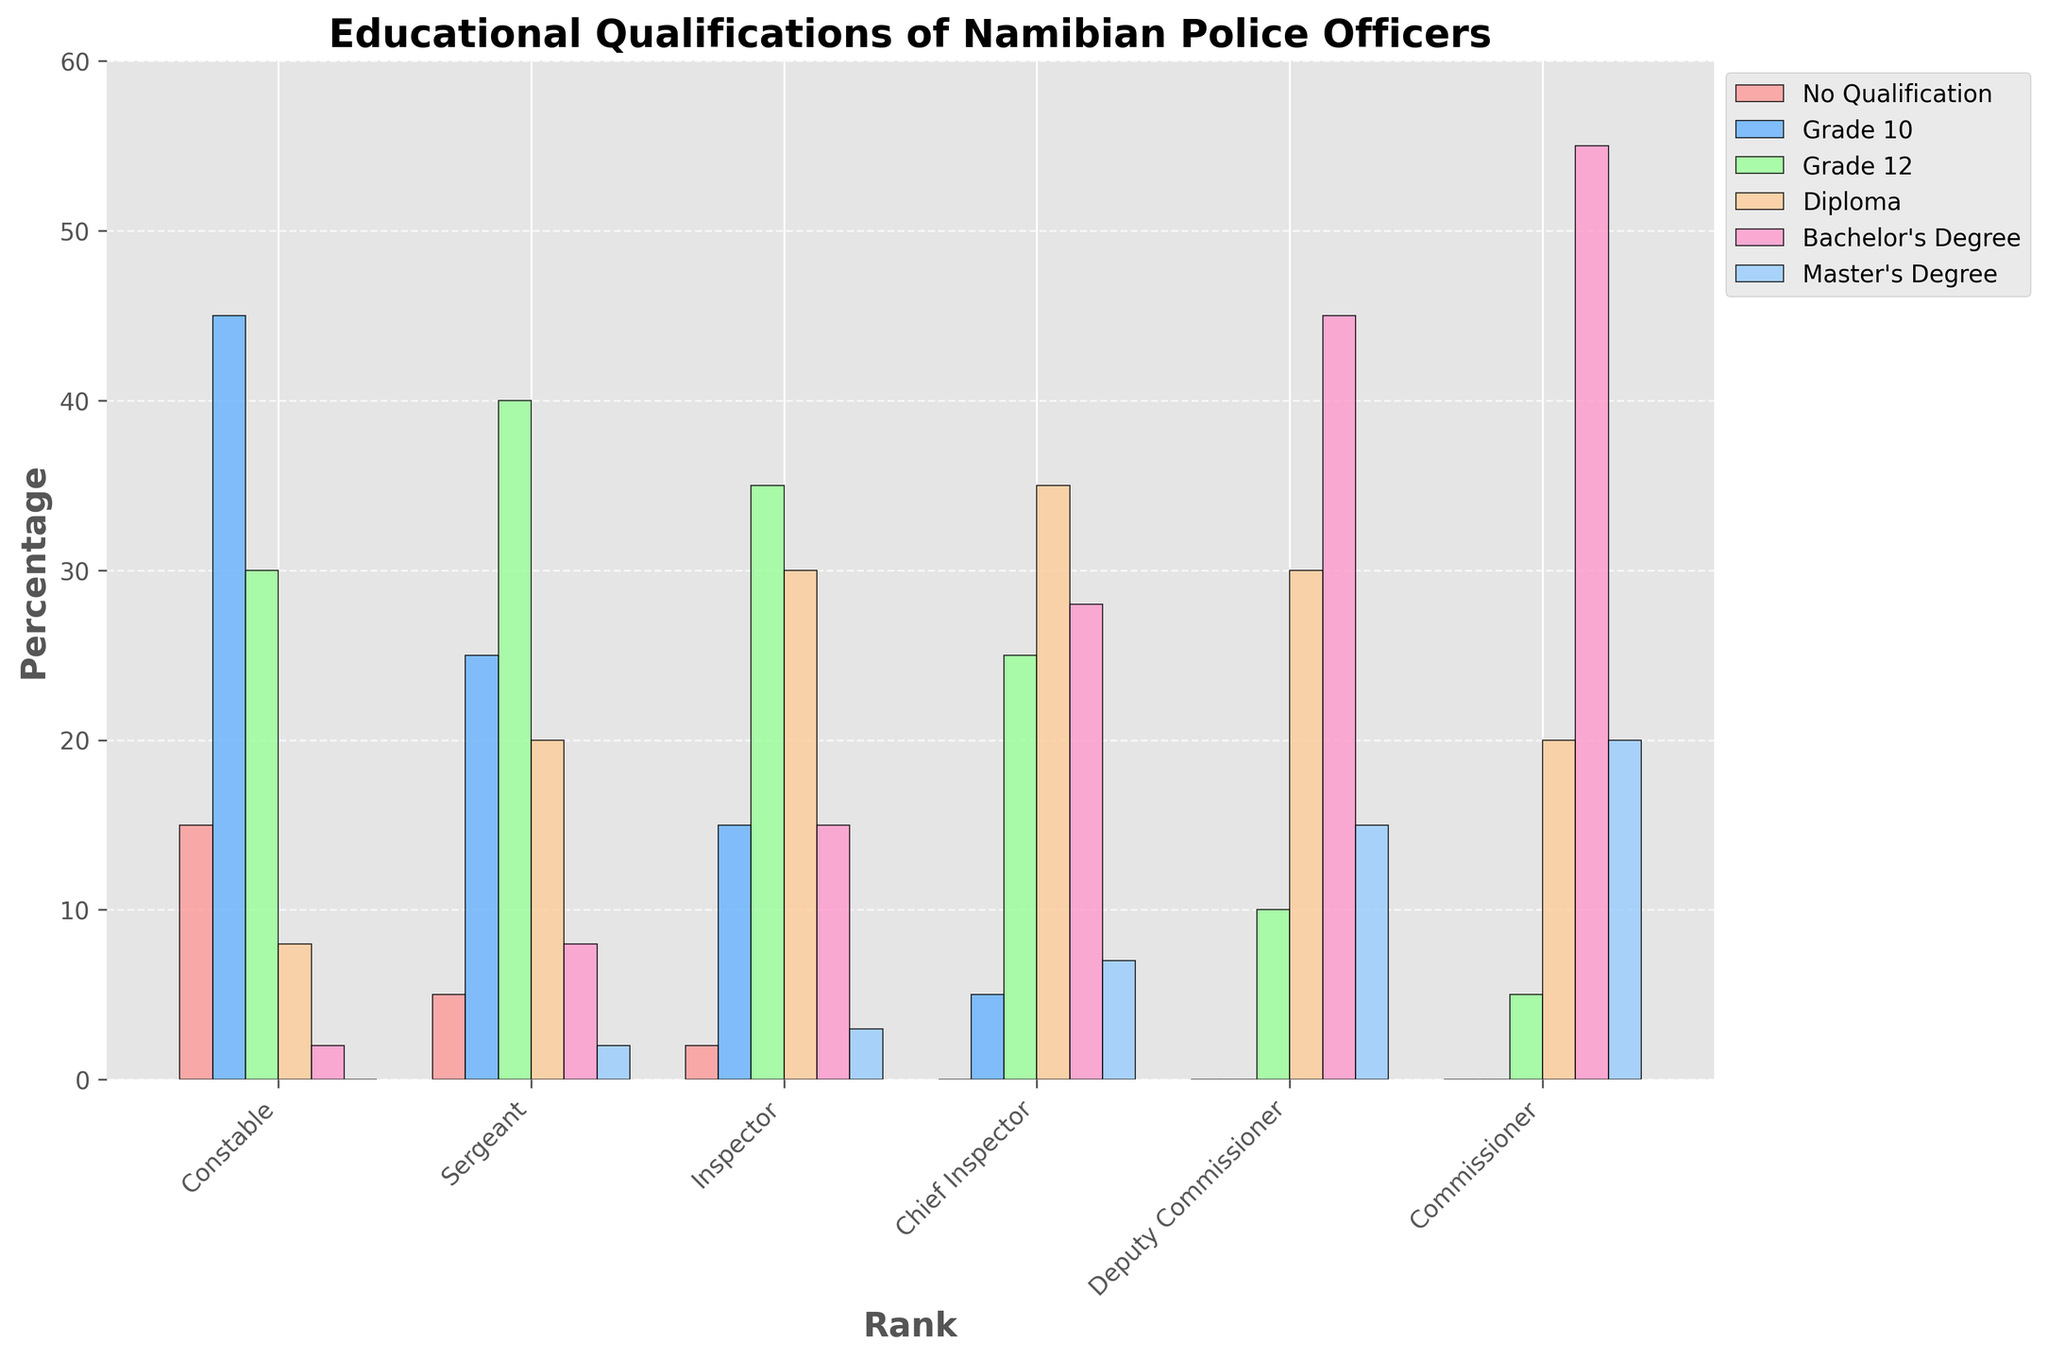What is the most common educational qualification among Constables? By looking at the height of the bars for the Constable rank, we can see that the bar for Grade 10 is the highest. This indicates that Grade 10 is the most common qualification.
Answer: Grade 10 Which rank has the highest percentage of Bachelor's Degree holders? To find the rank with the highest percentage of Bachelor's Degree holders, we compare the heights of the Bachelor's Degree bars across all ranks. The Commissioner rank has the highest bar for this qualification.
Answer: Commissioner How many more Sergeants have a Grade 12 qualification compared to Constables with the same qualification? First, observe the height of the Grade 12 bars for both Sergeants and Constables. The figures are 40 for Sergeants and 30 for Constables. The difference is 40 - 30 = 10.
Answer: 10 Which rank has the lowest count of officers with no qualification? We need to look at the heights of the bars representing "No Qualification". The Commissioner and Deputy Commissioner ranks have bars of zero height, so these ranks have the lowest count.
Answer: Commissioner, Deputy Commissioner What is the average percentage of officers with a Master's Degree among all ranks? Add the Master's Degree percentages for all ranks: 0+2+3+7+15+20 = 47. There are 6 ranks, so the average is 47 / 6 ≈ 7.8.
Answer: 7.8 Which educational qualification shows a steady increase in percentage from lower ranks to higher ranks? By visually inspecting the figure from left to right, observing that the bars steadily increase in height, the Bachelor's Degree qualification shows a clear increasing trend across the ranks.
Answer: Bachelor's Degree How does the percentage of Diploma holders in the Inspector rank compare to the Deputy Commissioner rank? Compare the heights of the Diploma bars for Inspector and Deputy Commissioner. Observing the figure, Inspector has 30 while Deputy Commissioner has 30 as well.
Answer: Equal Are there more Chief Inspectors with no qualification or Constables with a Bachelor's Degree? From the height of the bars, no Chief Inspectors have no qualification (0), and Constables with a Bachelor's Degree number 2.
Answer: Constables with a Bachelor's Degree Which rank has the highest diversity in educational qualifications? Diversity can be judged by comparing the range and distribution of the heights of the bars for each rank. Chief Inspector, Deputy Commissioner, and Commissioner have a variety of bars across all qualifications with reasonably significant heights.
Answer: Chief Inspector, Deputy Commissioner, Commissioner 